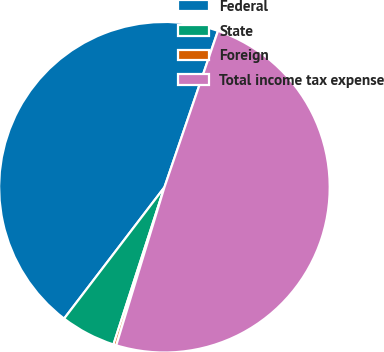<chart> <loc_0><loc_0><loc_500><loc_500><pie_chart><fcel>Federal<fcel>State<fcel>Foreign<fcel>Total income tax expense<nl><fcel>44.87%<fcel>5.39%<fcel>0.28%<fcel>49.46%<nl></chart> 